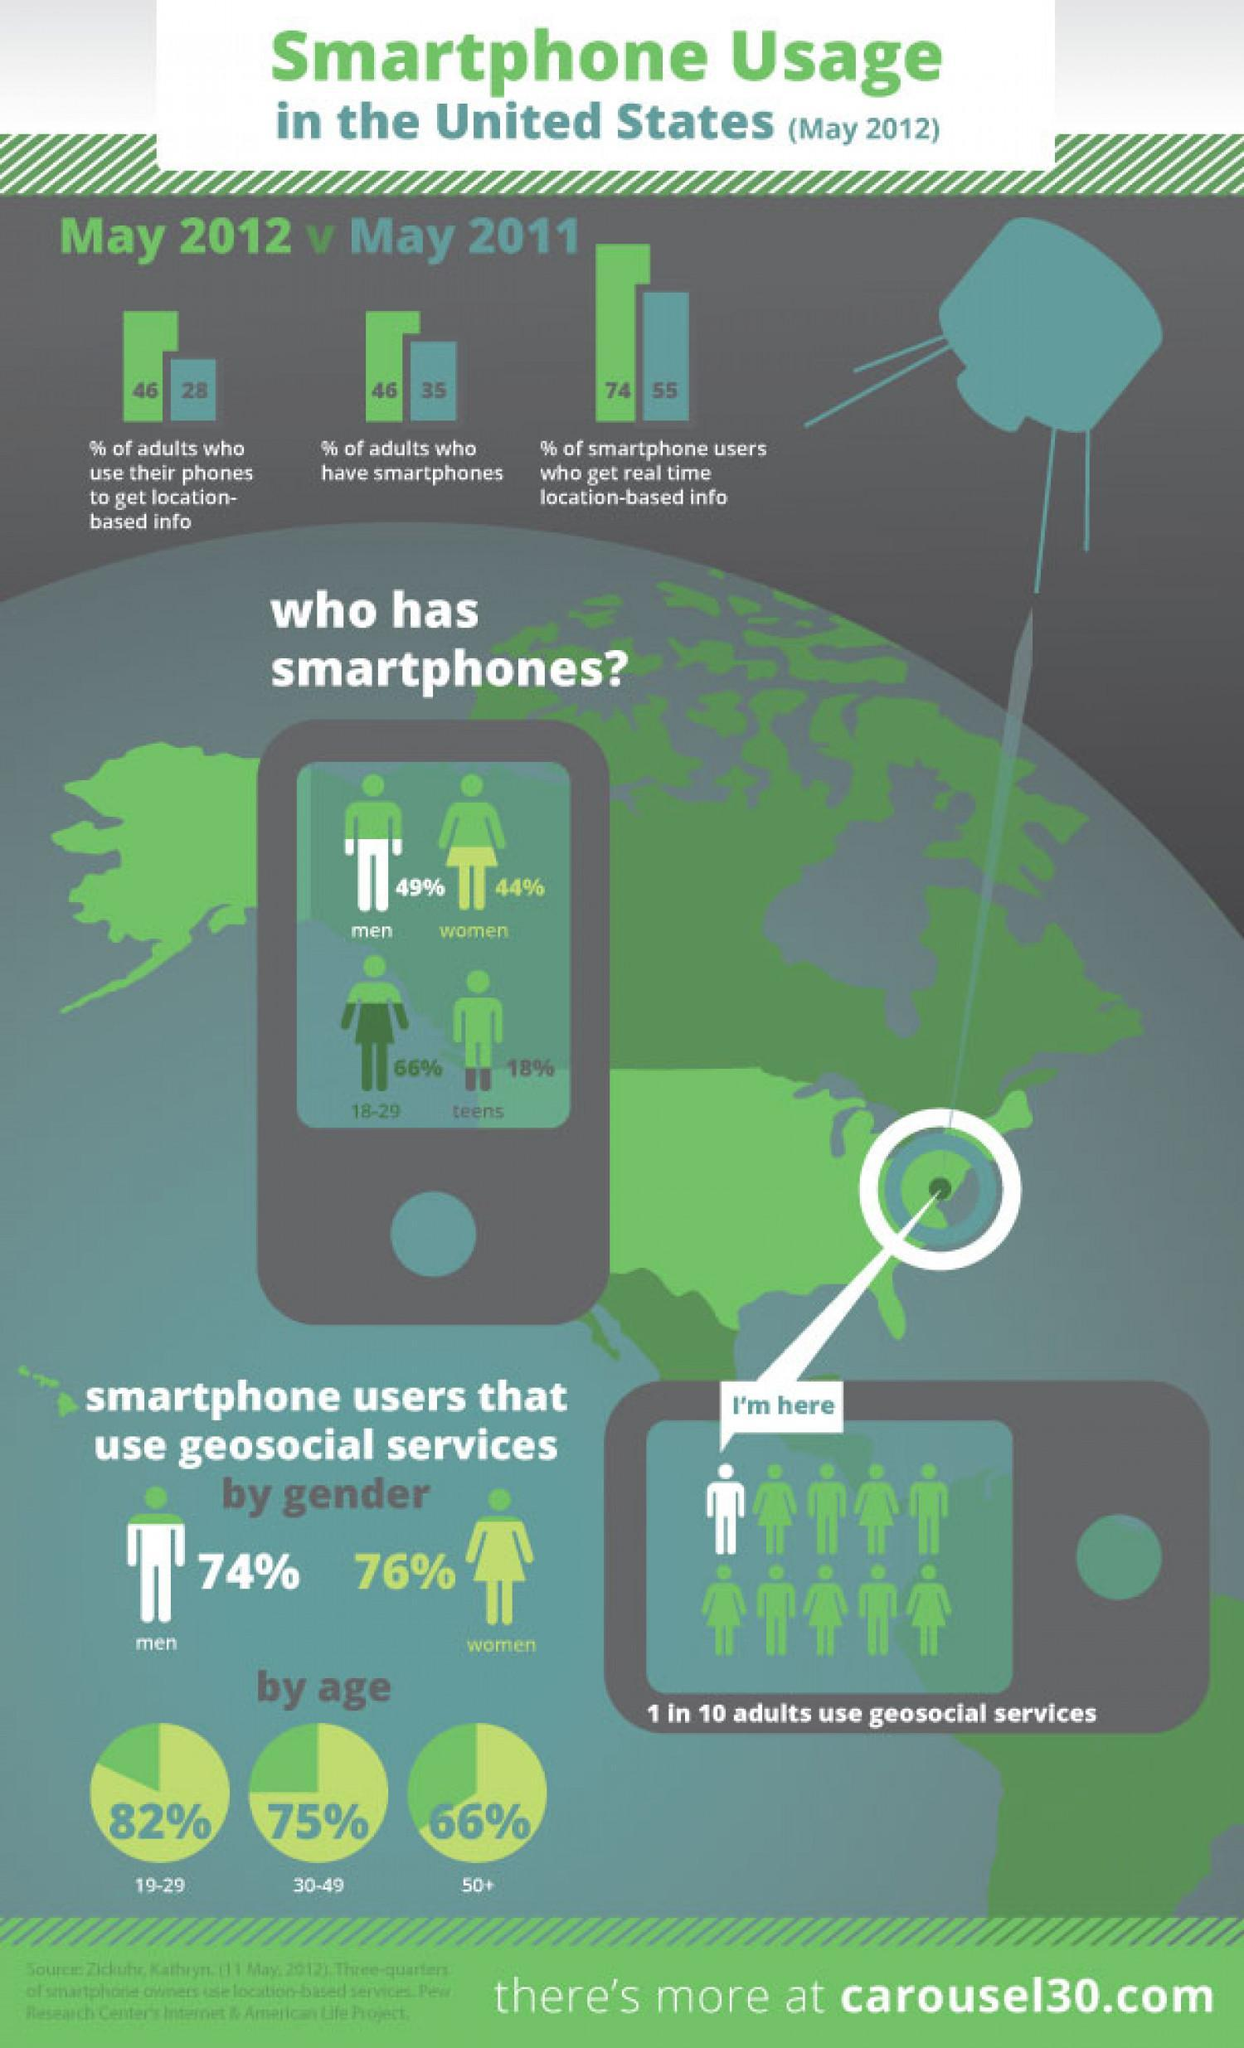in May 2011 what % of smartphone users got real time location-based info
Answer the question with a short phrase. 55 what was the increase in % of adults who have smart phones from May 2011 to May 2012 11 which age group smartphone users are the second highest in using geo social services 30-49 what percentage of adults use geosocial services 10 what percentage of men have smart phones 49% what percentage of females used smartphone geosocial services 76% 